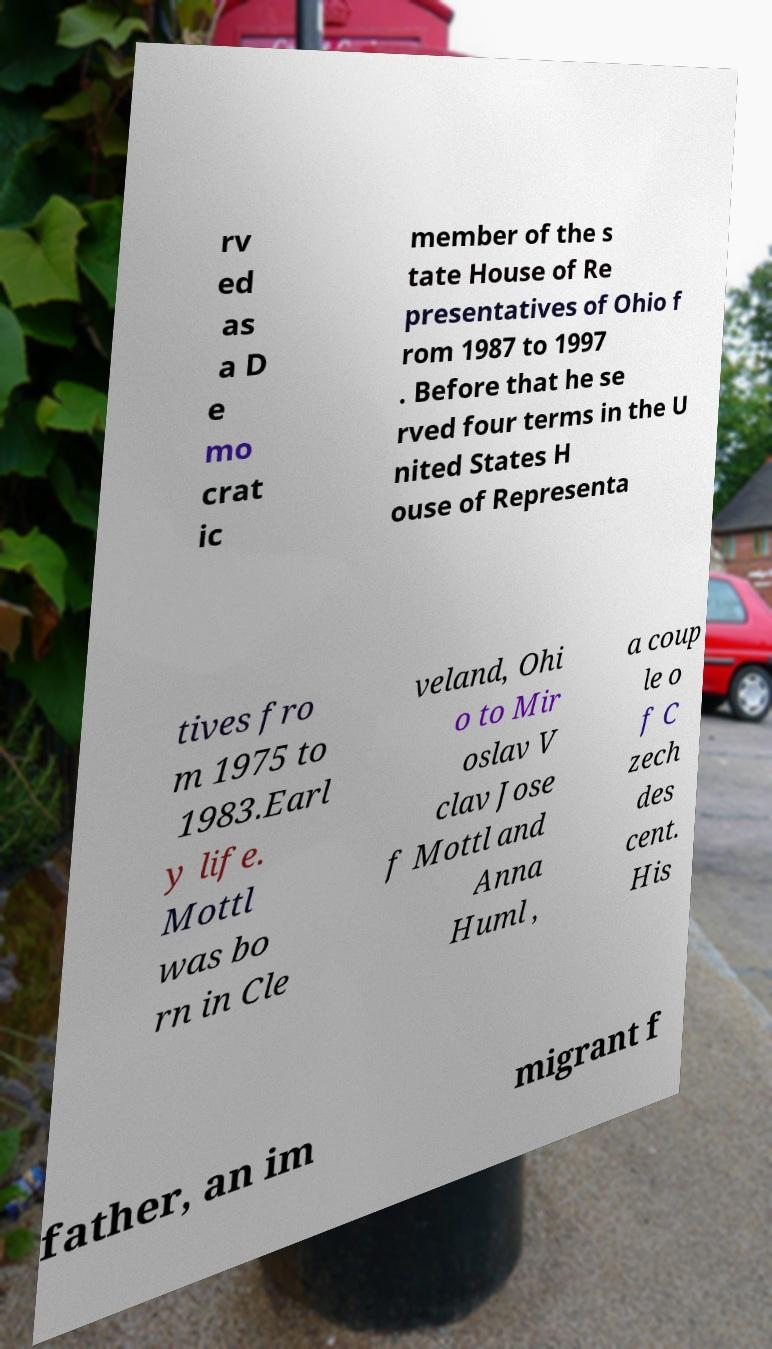Could you extract and type out the text from this image? rv ed as a D e mo crat ic member of the s tate House of Re presentatives of Ohio f rom 1987 to 1997 . Before that he se rved four terms in the U nited States H ouse of Representa tives fro m 1975 to 1983.Earl y life. Mottl was bo rn in Cle veland, Ohi o to Mir oslav V clav Jose f Mottl and Anna Huml , a coup le o f C zech des cent. His father, an im migrant f 